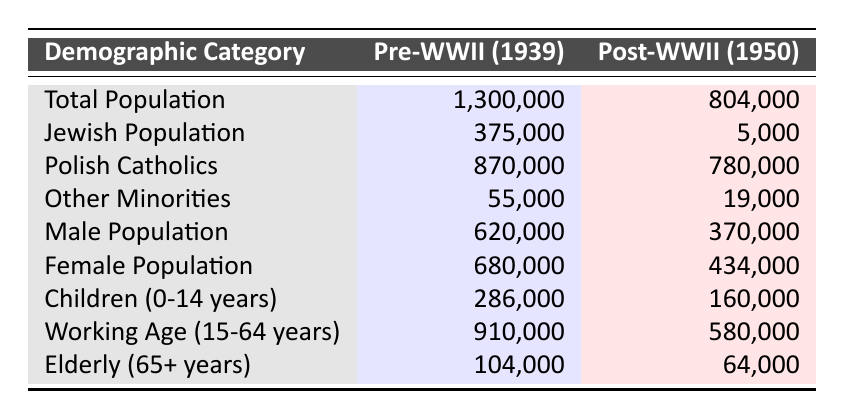What was the total population of Warsaw before World War II? The table indicates that the total population in 1939 was 1,300,000.
Answer: 1,300,000 What was the Jewish population after World War II? The table shows that the Jewish population in 1950 was 5,000.
Answer: 5,000 How many more Polish Catholics were in Warsaw before World War II compared to after? To find the difference, subtract the post-WWII Polish Catholics (780,000) from the pre-WWII population (870,000): 870,000 - 780,000 = 90,000.
Answer: 90,000 Did the male population decrease after World War II? Yes, the male population decreased from 620,000 in 1939 to 370,000 in 1950.
Answer: Yes What percentage of the total population was Jewish before World War II? To find the percentage, divide the Jewish population (375,000) by the total population (1,300,000) and multiply by 100: (375,000 / 1,300,000) * 100 ≈ 28.85%.
Answer: 28.85% What was the combined population of children (0-14 years) and elderly (65+ years) in Warsaw before World War II? The pre-WWII values for children were 286,000 and for the elderly were 104,000. Adding these gives: 286,000 + 104,000 = 390,000.
Answer: 390,000 Was there a smaller percentage of children (0-14 years) in 1950 compared to 1939? Yes, the number of children decreased from 286,000 in 1939 to 160,000 in 1950, reflecting a smaller percentage in 1950.
Answer: Yes How much did the working-age population (15-64 years) decrease from before to after World War II? The pre-WWII working-age population was 910,000 and post-WWII was 580,000. The decrease is 910,000 - 580,000 = 330,000.
Answer: 330,000 What was the ratio of female to male population in Warsaw after World War II? The female population was 434,000 and the male population was 370,000. The ratio is 434,000 / 370,000 ≈ 1.17:1, meaning there were more females than males.
Answer: 1.17:1 